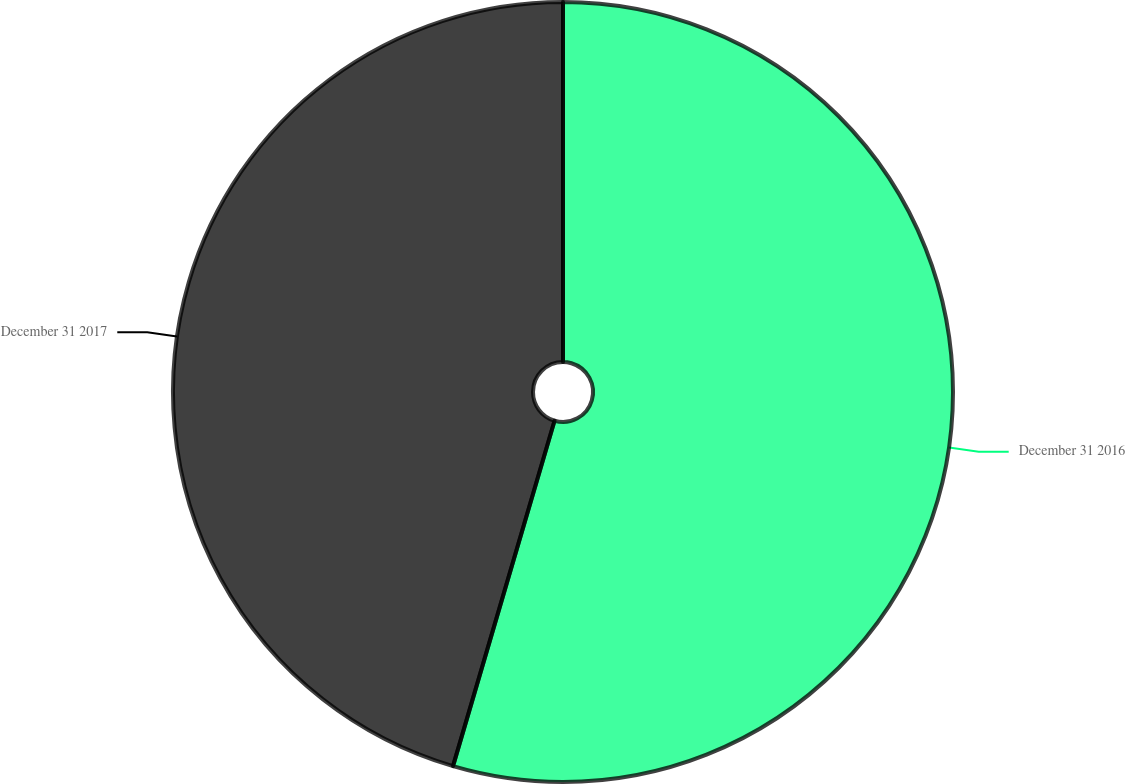Convert chart to OTSL. <chart><loc_0><loc_0><loc_500><loc_500><pie_chart><fcel>December 31 2016<fcel>December 31 2017<nl><fcel>54.55%<fcel>45.45%<nl></chart> 